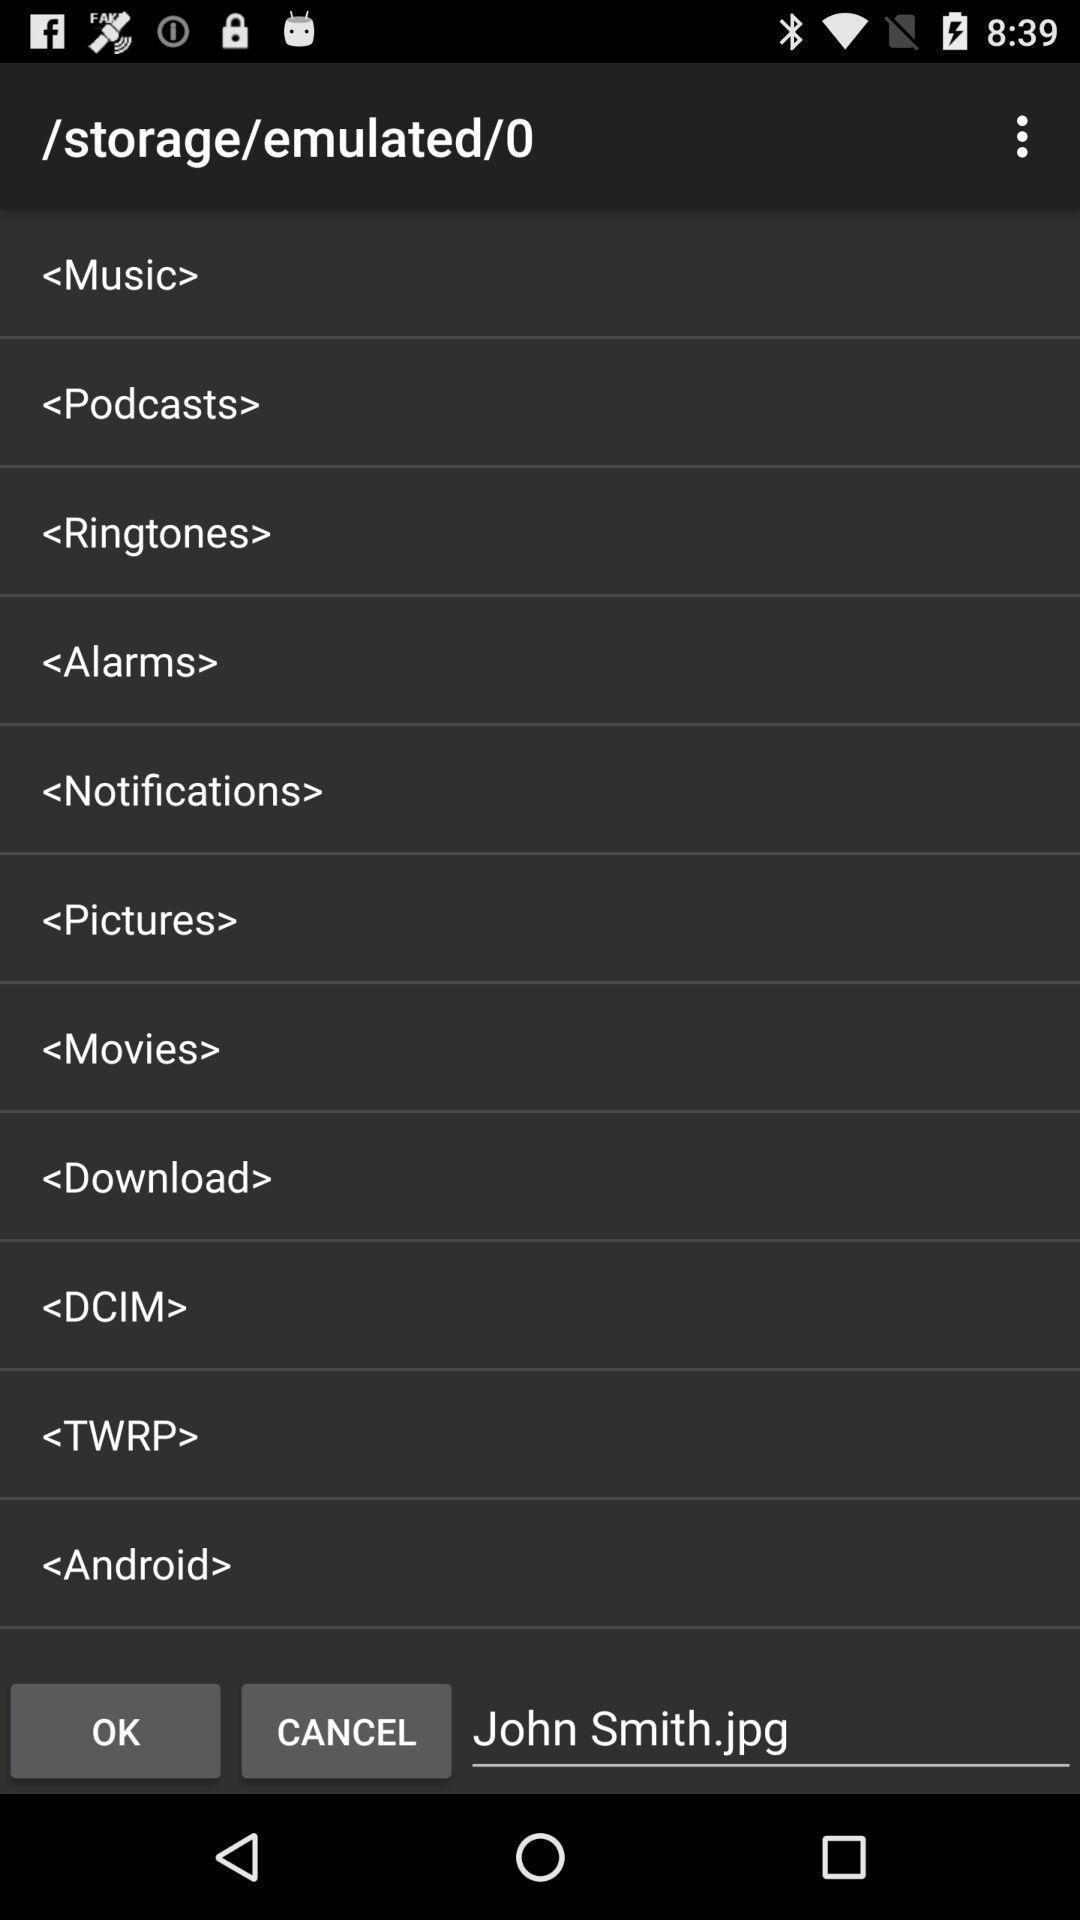What details can you identify in this image? Screen shows list of storage details. 